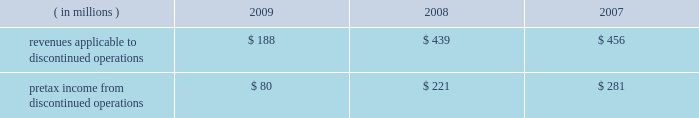Marathon oil corporation notes to consolidated financial statements been reported as discontinued operations in the consolidated statements of income and the consolidated statements of cash flows for all periods presented .
Discontinued operations 2014revenues and pretax income associated with our discontinued irish and gabonese operations are shown in the table : ( in millions ) 2009 2008 2007 .
Angola disposition 2013 in july 2009 , we entered into an agreement to sell an undivided 20 percent outside- operated interest in the production sharing contract and joint operating agreement in block 32 offshore angola for $ 1.3 billion , excluding any purchase price adjustments at closing , with an effective date of january 1 , 2009 .
The sale closed and we received net proceeds of $ 1.3 billion in february 2010 .
The pretax gain on the sale will be approximately $ 800 million .
We retained a 10 percent outside-operated interest in block 32 .
Gabon disposition 2013 in december 2009 , we closed the sale of our operated fields offshore gabon , receiving net proceeds of $ 269 million , after closing adjustments .
A $ 232 million pretax gain on this disposition was reported in discontinued operations for 2009 .
Permian basin disposition 2013 in june 2009 , we closed the sale of our operated and a portion of our outside- operated permian basin producing assets in new mexico and west texas for net proceeds after closing adjustments of $ 293 million .
A $ 196 million pretax gain on the sale was recorded .
Ireland dispositions 2013 in april 2009 , we closed the sale of our operated properties in ireland for net proceeds of $ 84 million , after adjusting for cash held by the sold subsidiary .
A $ 158 million pretax gain on the sale was recorded .
As a result of this sale , we terminated our pension plan in ireland , incurring a charge of $ 18 million .
In june 2009 , we entered into an agreement to sell the subsidiary holding our 19 percent outside-operated interest in the corrib natural gas development offshore ireland .
Total proceeds were estimated to range between $ 235 million and $ 400 million , subject to the timing of first commercial gas at corrib and closing adjustments .
At closing on july 30 , 2009 , the initial $ 100 million payment plus closing adjustments was received .
The fair value of the proceeds was estimated to be $ 311 million .
Fair value of anticipated sale proceeds includes ( i ) $ 100 million received at closing , ( ii ) $ 135 million minimum amount due at the earlier of first gas or december 31 , 2012 , and ( iii ) a range of zero to $ 165 million of contingent proceeds subject to the timing of first commercial gas .
A $ 154 million impairment of the held for sale asset was recognized in discontinued operations in the second quarter of 2009 ( see note 16 ) since the fair value of the disposal group was less than the net book value .
Final proceeds will range between $ 135 million ( minimum amount ) to $ 300 million and are due on the earlier of first commercial gas or december 31 , 2012 .
The fair value of the expected final proceeds was recorded as an asset at closing .
As a result of new public information in the fourth quarter of 2009 , a writeoff was recorded on the contingent portion of the proceeds ( see note 10 ) .
Existing guarantees of our subsidiaries 2019 performance issued to irish government entities will remain in place after the sales until the purchasers issue similar guarantees to replace them .
The guarantees , related to asset retirement obligations and natural gas production levels , have been indemnified by the purchasers .
The fair value of these guarantees is not significant .
Norwegian disposition 2013 on october 31 , 2008 , we closed the sale of our norwegian outside-operated e&p properties and undeveloped offshore acreage in the heimdal area of the norwegian north sea for net proceeds of $ 301 million , with a pretax gain of $ 254 million as of december 31 , 2008 .
Pilot travel centers disposition 2013 on october 8 , 2008 , we completed the sale of our 50 percent ownership interest in ptc .
Sale proceeds were $ 625 million , with a pretax gain on the sale of $ 126 million .
Immediately preceding the sale , we received a $ 75 million partial redemption of our ownership interest from ptc that was accounted for as a return of investment .
This was an investment of our rm&t segment. .
By how much did revenues applicable to discontinued operations decrease from 2007 to 2009? 
Computations: ((188 - 456) / 456)
Answer: -0.58772. 